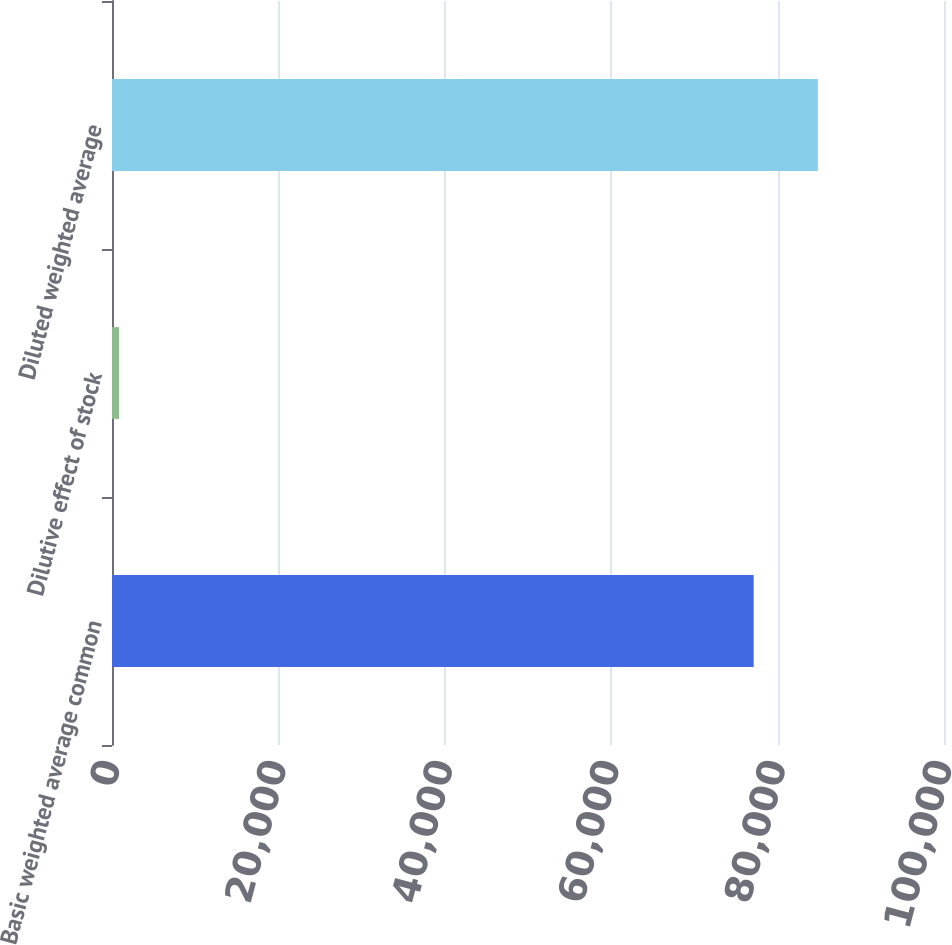Convert chart to OTSL. <chart><loc_0><loc_0><loc_500><loc_500><bar_chart><fcel>Basic weighted average common<fcel>Dilutive effect of stock<fcel>Diluted weighted average<nl><fcel>77126<fcel>846<fcel>84838.6<nl></chart> 